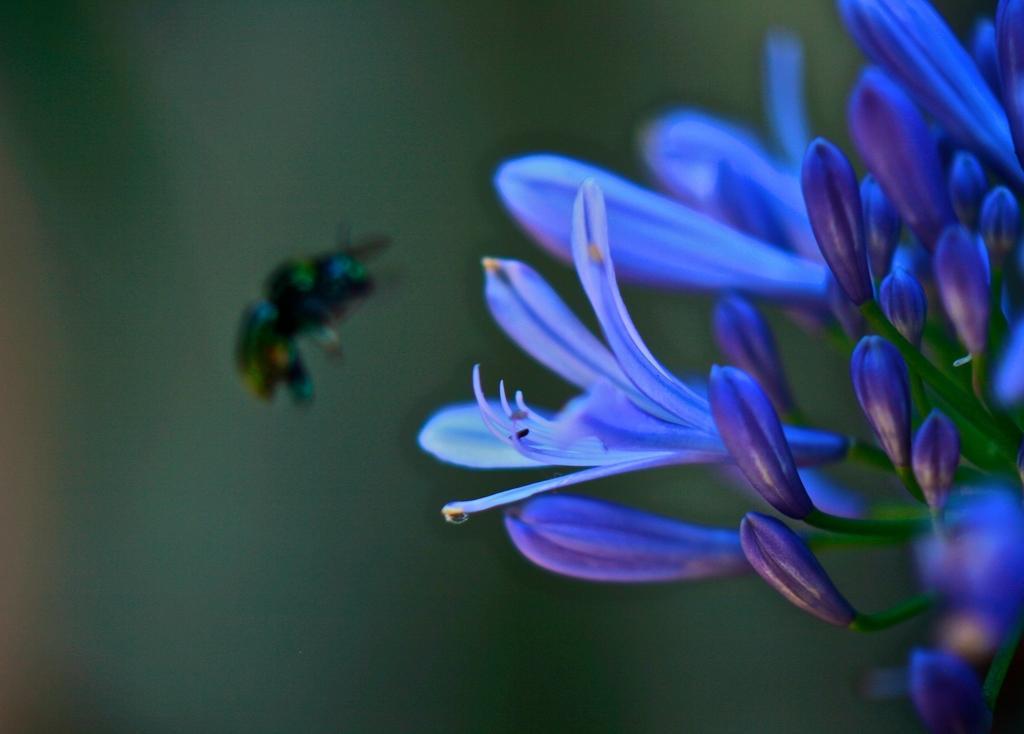In one or two sentences, can you explain what this image depicts? In this image I can see few flowers which are blue and purple in color. I can see an insect flying in the air and the blurry background. 